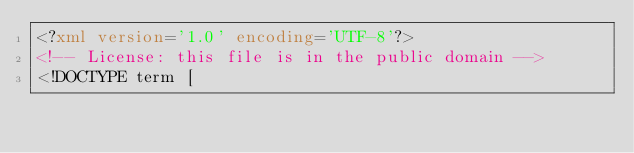Convert code to text. <code><loc_0><loc_0><loc_500><loc_500><_XML_><?xml version='1.0' encoding='UTF-8'?>
<!-- License: this file is in the public domain -->
<!DOCTYPE term [</code> 